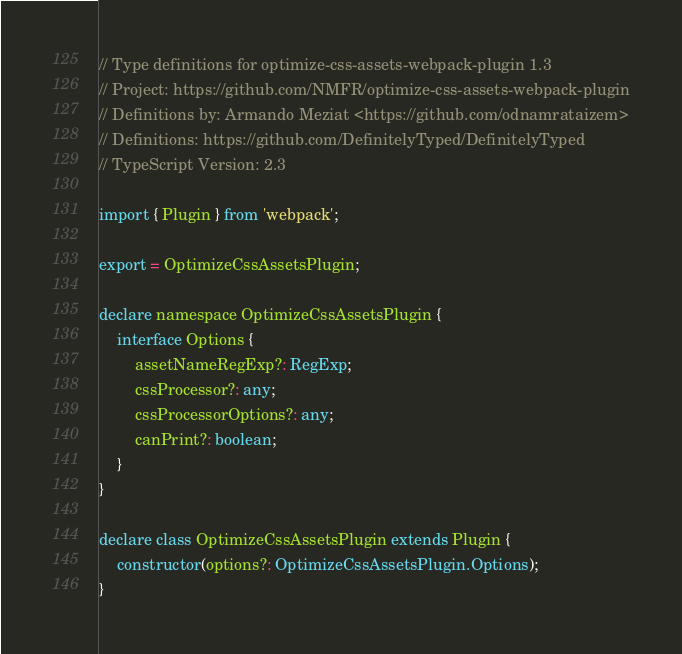<code> <loc_0><loc_0><loc_500><loc_500><_TypeScript_>// Type definitions for optimize-css-assets-webpack-plugin 1.3
// Project: https://github.com/NMFR/optimize-css-assets-webpack-plugin
// Definitions by: Armando Meziat <https://github.com/odnamrataizem>
// Definitions: https://github.com/DefinitelyTyped/DefinitelyTyped
// TypeScript Version: 2.3

import { Plugin } from 'webpack';

export = OptimizeCssAssetsPlugin;

declare namespace OptimizeCssAssetsPlugin {
	interface Options {
		assetNameRegExp?: RegExp;
		cssProcessor?: any;
		cssProcessorOptions?: any;
		canPrint?: boolean;
	}
}

declare class OptimizeCssAssetsPlugin extends Plugin {
	constructor(options?: OptimizeCssAssetsPlugin.Options);
}
</code> 